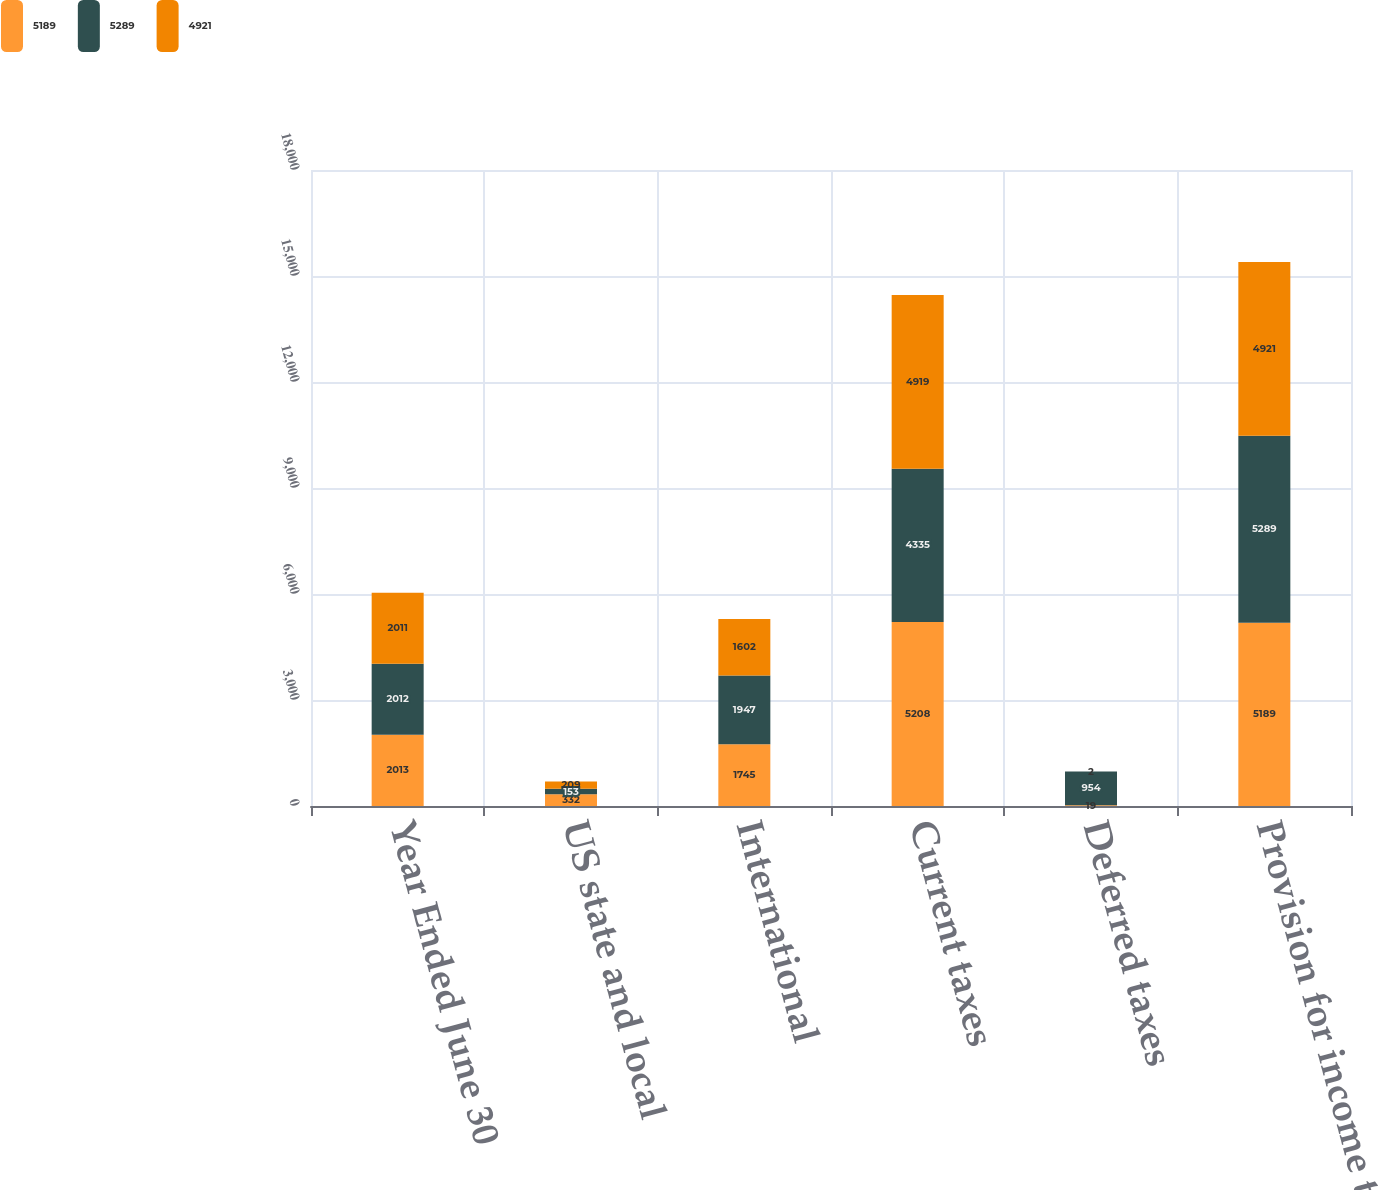Convert chart. <chart><loc_0><loc_0><loc_500><loc_500><stacked_bar_chart><ecel><fcel>Year Ended June 30<fcel>US state and local<fcel>International<fcel>Current taxes<fcel>Deferred taxes<fcel>Provision for income taxes<nl><fcel>5189<fcel>2013<fcel>332<fcel>1745<fcel>5208<fcel>19<fcel>5189<nl><fcel>5289<fcel>2012<fcel>153<fcel>1947<fcel>4335<fcel>954<fcel>5289<nl><fcel>4921<fcel>2011<fcel>209<fcel>1602<fcel>4919<fcel>2<fcel>4921<nl></chart> 